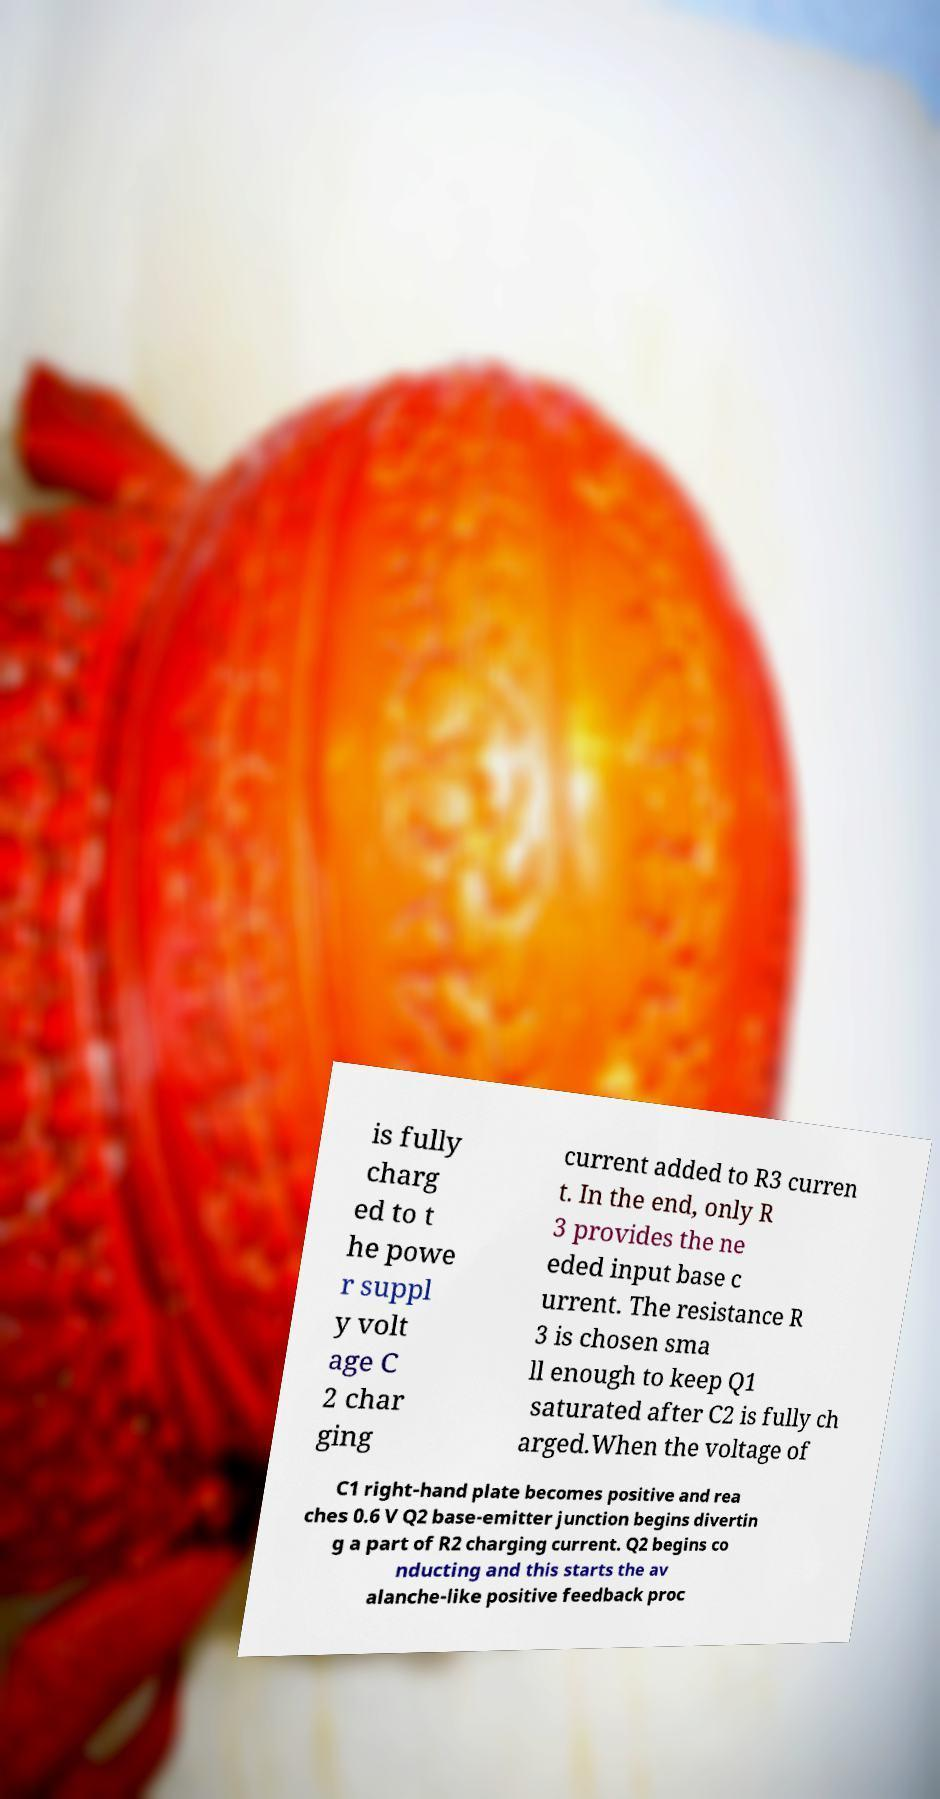Please read and relay the text visible in this image. What does it say? is fully charg ed to t he powe r suppl y volt age C 2 char ging current added to R3 curren t. In the end, only R 3 provides the ne eded input base c urrent. The resistance R 3 is chosen sma ll enough to keep Q1 saturated after C2 is fully ch arged.When the voltage of C1 right-hand plate becomes positive and rea ches 0.6 V Q2 base-emitter junction begins divertin g a part of R2 charging current. Q2 begins co nducting and this starts the av alanche-like positive feedback proc 